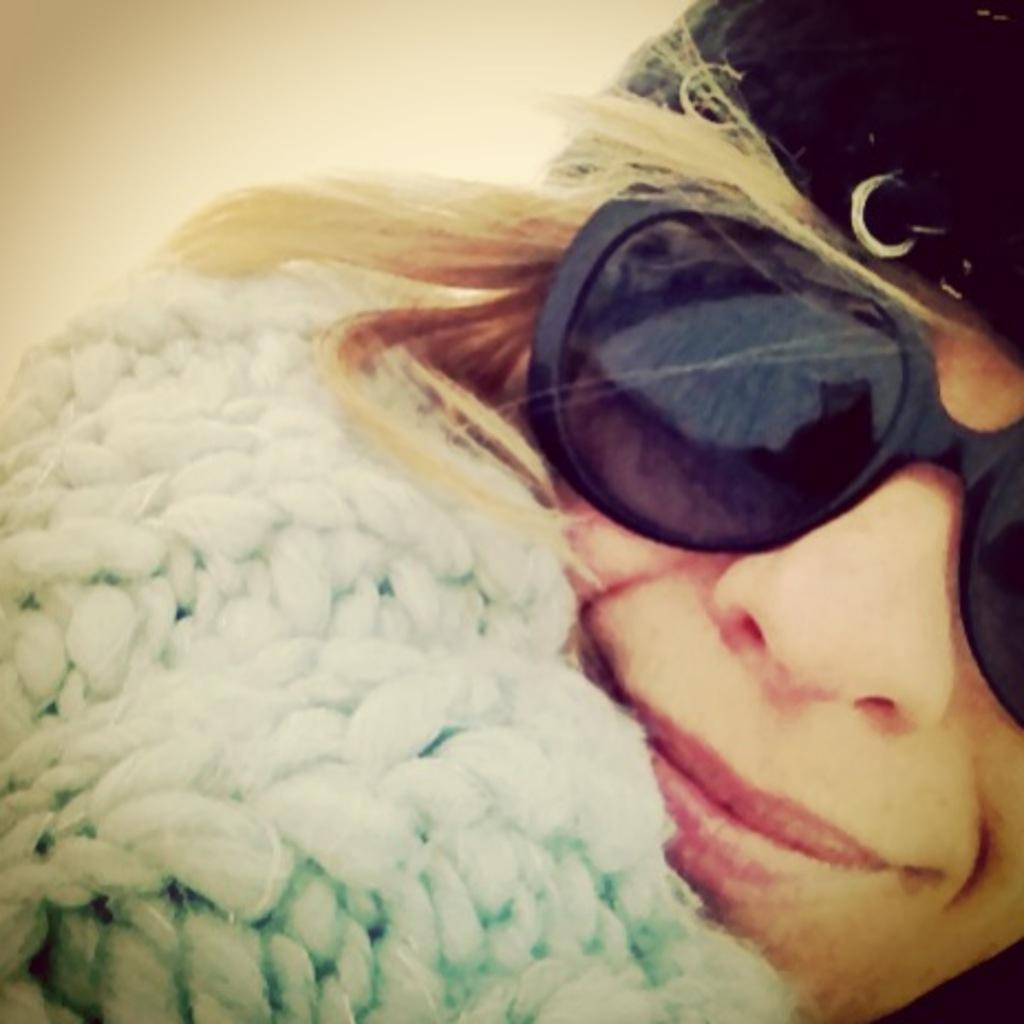What is the main subject of the image? There is a person in the image. What type of protective gear is the person wearing? The person is wearing goggles on their eyes. What type of headwear is the person wearing? The person is wearing a cap on their head. What type of sister is the person in the image? The image does not provide any information about the person's siblings, so it cannot be determined if they have a sister or not. What is the person's mind doing in the image? The image does not provide any information about the person's mental state or actions, so it cannot be determined what their mind is doing. 